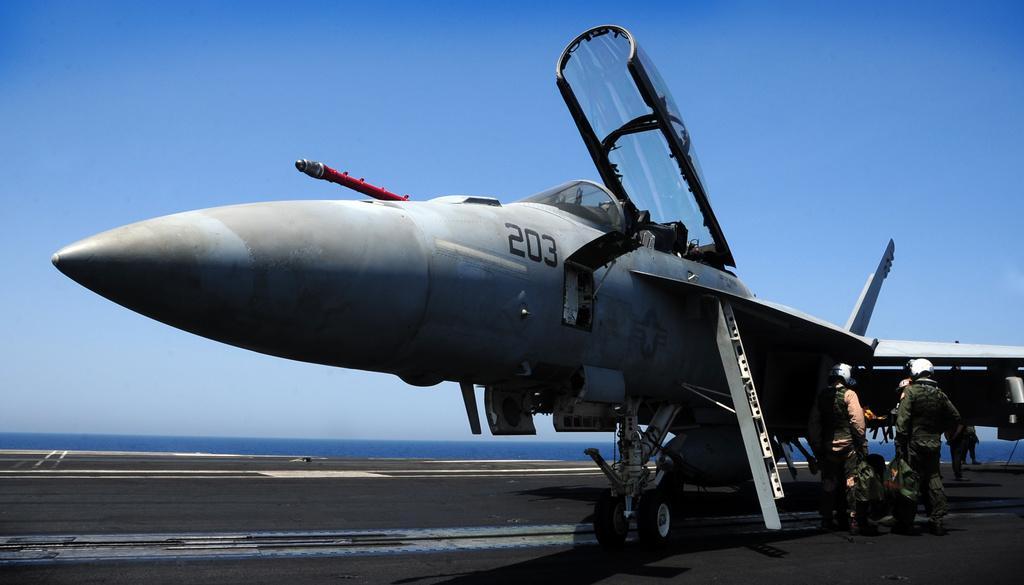Describe this image in one or two sentences. In the picture I can see a plane which is on the run way and there are few persons standing beside it in the right corner and there is water in the background. 